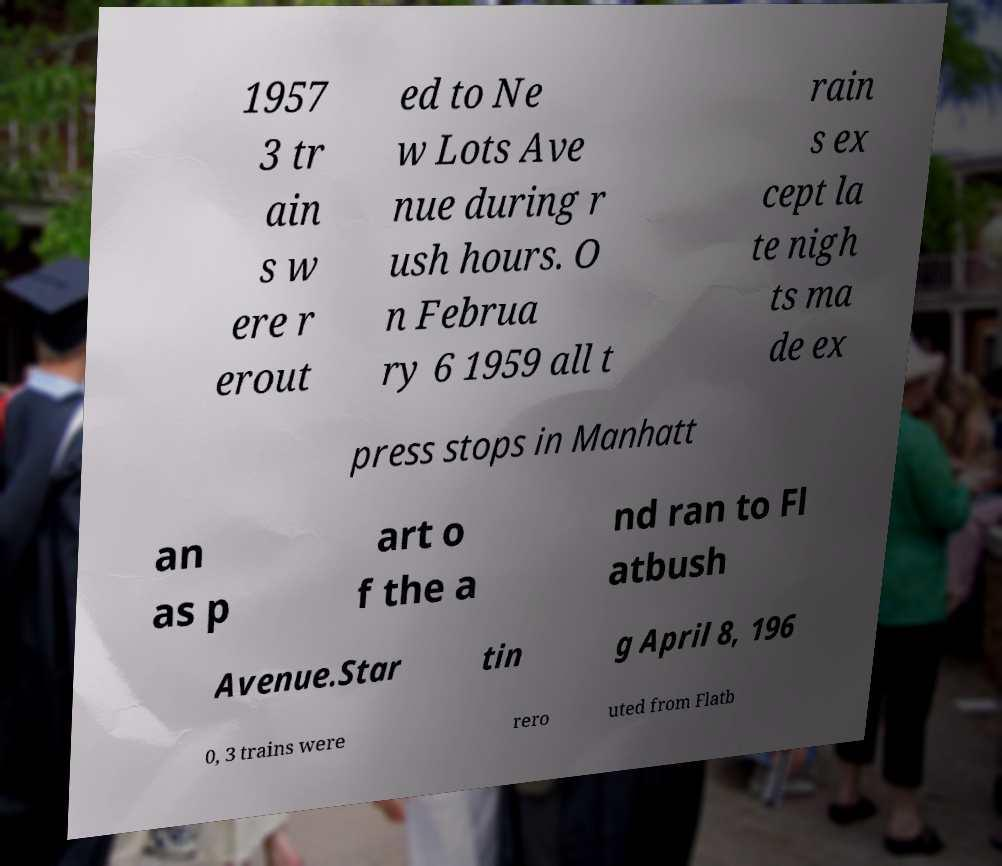Could you assist in decoding the text presented in this image and type it out clearly? 1957 3 tr ain s w ere r erout ed to Ne w Lots Ave nue during r ush hours. O n Februa ry 6 1959 all t rain s ex cept la te nigh ts ma de ex press stops in Manhatt an as p art o f the a nd ran to Fl atbush Avenue.Star tin g April 8, 196 0, 3 trains were rero uted from Flatb 